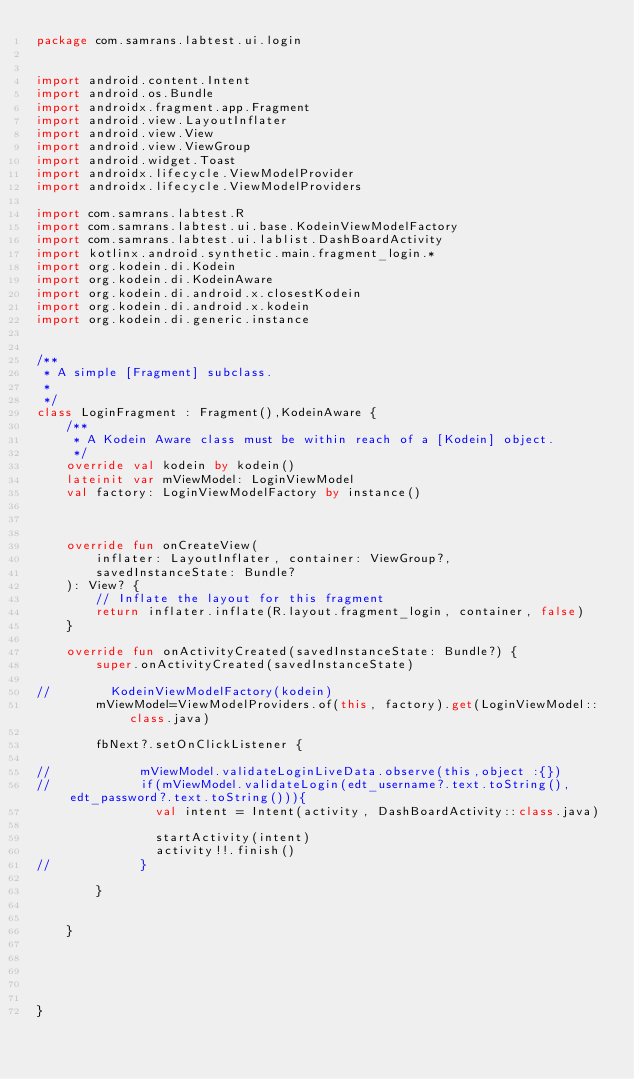<code> <loc_0><loc_0><loc_500><loc_500><_Kotlin_>package com.samrans.labtest.ui.login


import android.content.Intent
import android.os.Bundle
import androidx.fragment.app.Fragment
import android.view.LayoutInflater
import android.view.View
import android.view.ViewGroup
import android.widget.Toast
import androidx.lifecycle.ViewModelProvider
import androidx.lifecycle.ViewModelProviders

import com.samrans.labtest.R
import com.samrans.labtest.ui.base.KodeinViewModelFactory
import com.samrans.labtest.ui.lablist.DashBoardActivity
import kotlinx.android.synthetic.main.fragment_login.*
import org.kodein.di.Kodein
import org.kodein.di.KodeinAware
import org.kodein.di.android.x.closestKodein
import org.kodein.di.android.x.kodein
import org.kodein.di.generic.instance


/**
 * A simple [Fragment] subclass.
 *
 */
class LoginFragment : Fragment(),KodeinAware {
    /**
     * A Kodein Aware class must be within reach of a [Kodein] object.
     */
    override val kodein by kodein()
    lateinit var mViewModel: LoginViewModel
    val factory: LoginViewModelFactory by instance()



    override fun onCreateView(
        inflater: LayoutInflater, container: ViewGroup?,
        savedInstanceState: Bundle?
    ): View? {
        // Inflate the layout for this fragment
        return inflater.inflate(R.layout.fragment_login, container, false)
    }

    override fun onActivityCreated(savedInstanceState: Bundle?) {
        super.onActivityCreated(savedInstanceState)

//        KodeinViewModelFactory(kodein)
        mViewModel=ViewModelProviders.of(this, factory).get(LoginViewModel::class.java)

        fbNext?.setOnClickListener {

//            mViewModel.validateLoginLiveData.observe(this,object :{})
//            if(mViewModel.validateLogin(edt_username?.text.toString(),edt_password?.text.toString())){
                val intent = Intent(activity, DashBoardActivity::class.java)

                startActivity(intent)
                activity!!.finish()
//            }

        }


    }





}
</code> 